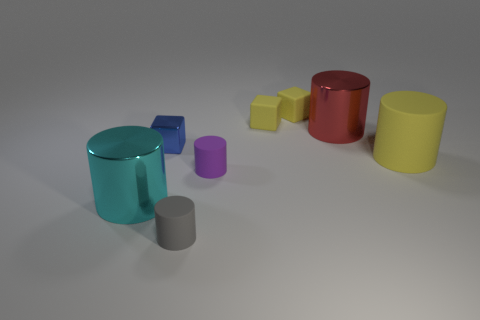The other tiny object that is the same shape as the tiny purple object is what color?
Provide a short and direct response. Gray. What size is the yellow matte cylinder?
Your response must be concise. Large. How many balls are either big things or cyan metallic things?
Your answer should be very brief. 0. The cyan metal thing that is the same shape as the large red thing is what size?
Your response must be concise. Large. How many blue metal blocks are there?
Provide a short and direct response. 1. There is a small purple matte thing; is it the same shape as the big rubber thing that is on the right side of the tiny gray rubber thing?
Your response must be concise. Yes. There is a rubber cylinder on the right side of the tiny purple cylinder; what is its size?
Keep it short and to the point. Large. What material is the gray object?
Provide a succinct answer. Rubber. Does the matte thing that is in front of the large cyan metallic thing have the same shape as the purple rubber object?
Keep it short and to the point. Yes. Are there any cyan metal cylinders that have the same size as the red metal cylinder?
Make the answer very short. Yes. 